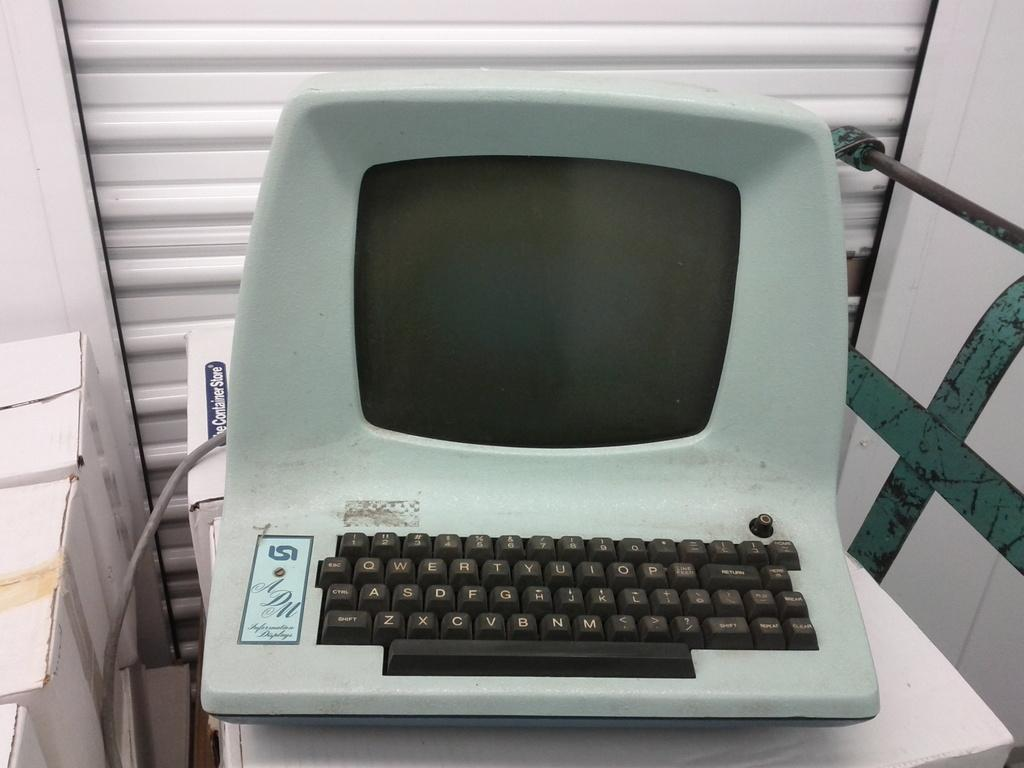<image>
Create a compact narrative representing the image presented. A cardboard box with the words The Container Store on it. 